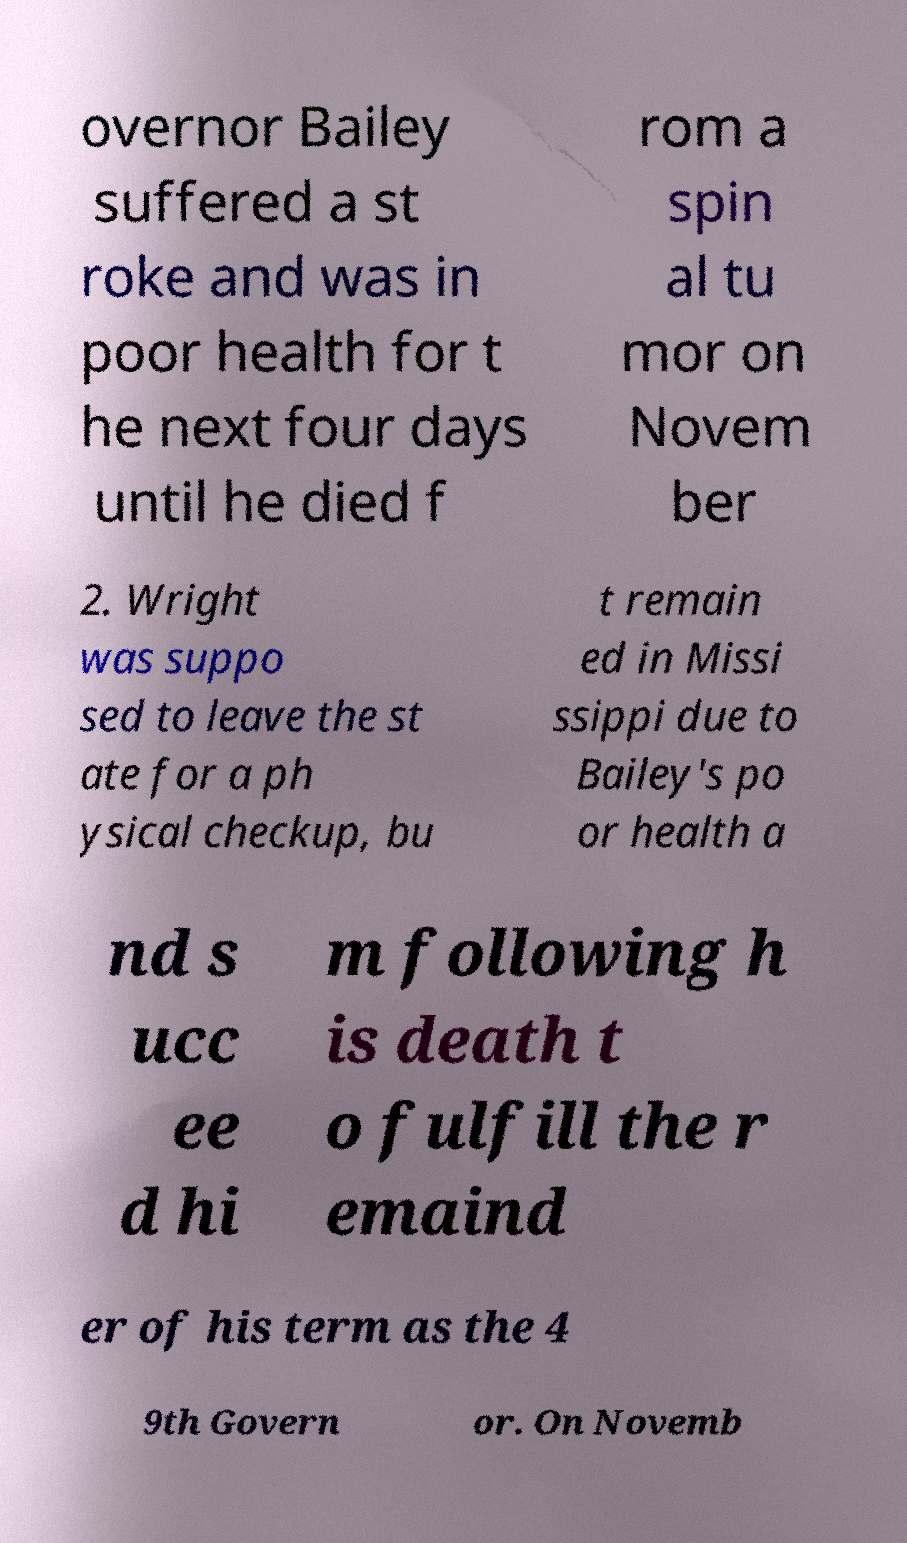Can you read and provide the text displayed in the image?This photo seems to have some interesting text. Can you extract and type it out for me? overnor Bailey suffered a st roke and was in poor health for t he next four days until he died f rom a spin al tu mor on Novem ber 2. Wright was suppo sed to leave the st ate for a ph ysical checkup, bu t remain ed in Missi ssippi due to Bailey's po or health a nd s ucc ee d hi m following h is death t o fulfill the r emaind er of his term as the 4 9th Govern or. On Novemb 